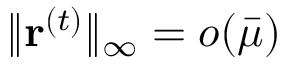Convert formula to latex. <formula><loc_0><loc_0><loc_500><loc_500>\| r ^ { ( t ) } \| _ { \infty } = o ( \bar { \mu } )</formula> 